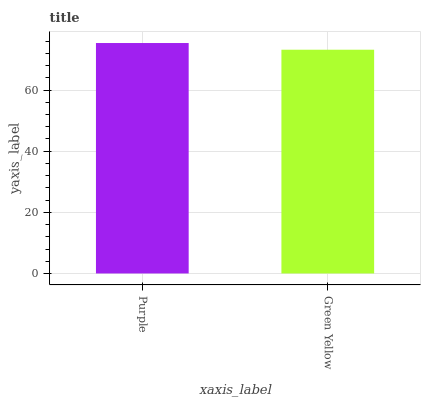Is Green Yellow the minimum?
Answer yes or no. Yes. Is Purple the maximum?
Answer yes or no. Yes. Is Green Yellow the maximum?
Answer yes or no. No. Is Purple greater than Green Yellow?
Answer yes or no. Yes. Is Green Yellow less than Purple?
Answer yes or no. Yes. Is Green Yellow greater than Purple?
Answer yes or no. No. Is Purple less than Green Yellow?
Answer yes or no. No. Is Purple the high median?
Answer yes or no. Yes. Is Green Yellow the low median?
Answer yes or no. Yes. Is Green Yellow the high median?
Answer yes or no. No. Is Purple the low median?
Answer yes or no. No. 